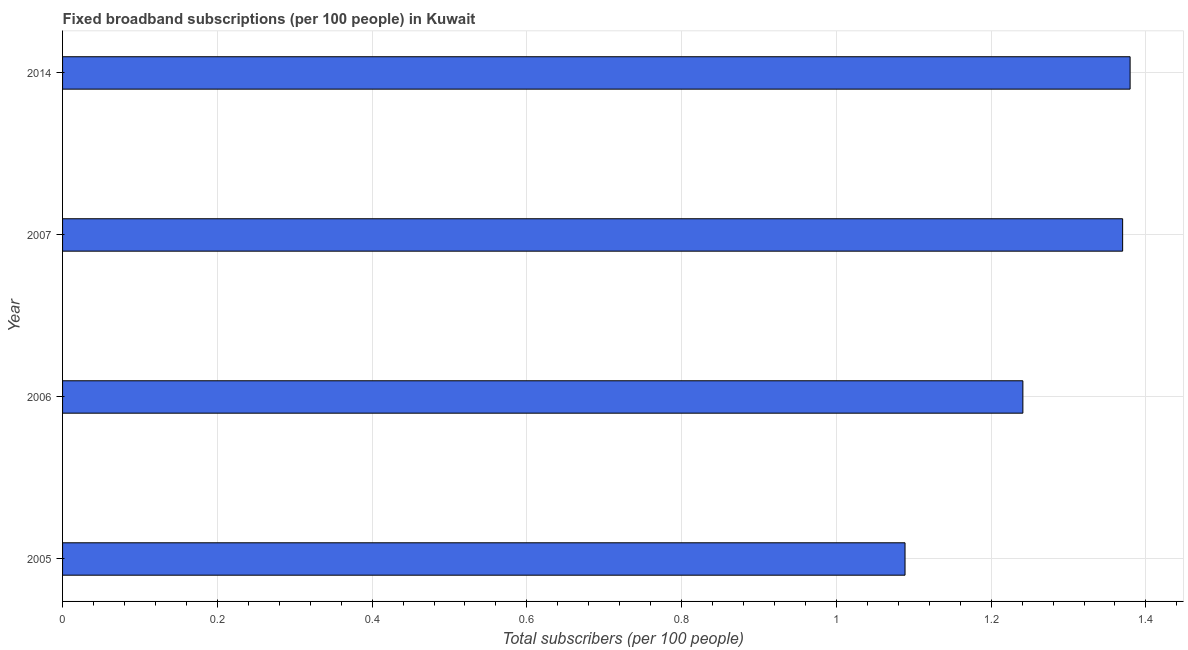Does the graph contain any zero values?
Provide a short and direct response. No. What is the title of the graph?
Your response must be concise. Fixed broadband subscriptions (per 100 people) in Kuwait. What is the label or title of the X-axis?
Keep it short and to the point. Total subscribers (per 100 people). What is the label or title of the Y-axis?
Make the answer very short. Year. What is the total number of fixed broadband subscriptions in 2007?
Give a very brief answer. 1.37. Across all years, what is the maximum total number of fixed broadband subscriptions?
Keep it short and to the point. 1.38. Across all years, what is the minimum total number of fixed broadband subscriptions?
Offer a very short reply. 1.09. In which year was the total number of fixed broadband subscriptions maximum?
Make the answer very short. 2014. What is the sum of the total number of fixed broadband subscriptions?
Your answer should be very brief. 5.08. What is the difference between the total number of fixed broadband subscriptions in 2005 and 2007?
Provide a succinct answer. -0.28. What is the average total number of fixed broadband subscriptions per year?
Provide a short and direct response. 1.27. What is the median total number of fixed broadband subscriptions?
Ensure brevity in your answer.  1.31. What is the difference between the highest and the second highest total number of fixed broadband subscriptions?
Offer a very short reply. 0.01. What is the difference between the highest and the lowest total number of fixed broadband subscriptions?
Offer a very short reply. 0.29. Are all the bars in the graph horizontal?
Your response must be concise. Yes. What is the Total subscribers (per 100 people) in 2005?
Your answer should be compact. 1.09. What is the Total subscribers (per 100 people) in 2006?
Ensure brevity in your answer.  1.24. What is the Total subscribers (per 100 people) of 2007?
Your answer should be compact. 1.37. What is the Total subscribers (per 100 people) in 2014?
Your response must be concise. 1.38. What is the difference between the Total subscribers (per 100 people) in 2005 and 2006?
Make the answer very short. -0.15. What is the difference between the Total subscribers (per 100 people) in 2005 and 2007?
Your answer should be compact. -0.28. What is the difference between the Total subscribers (per 100 people) in 2005 and 2014?
Keep it short and to the point. -0.29. What is the difference between the Total subscribers (per 100 people) in 2006 and 2007?
Your response must be concise. -0.13. What is the difference between the Total subscribers (per 100 people) in 2006 and 2014?
Provide a succinct answer. -0.14. What is the difference between the Total subscribers (per 100 people) in 2007 and 2014?
Your response must be concise. -0.01. What is the ratio of the Total subscribers (per 100 people) in 2005 to that in 2006?
Your answer should be compact. 0.88. What is the ratio of the Total subscribers (per 100 people) in 2005 to that in 2007?
Offer a very short reply. 0.8. What is the ratio of the Total subscribers (per 100 people) in 2005 to that in 2014?
Provide a succinct answer. 0.79. What is the ratio of the Total subscribers (per 100 people) in 2006 to that in 2007?
Your answer should be compact. 0.91. 